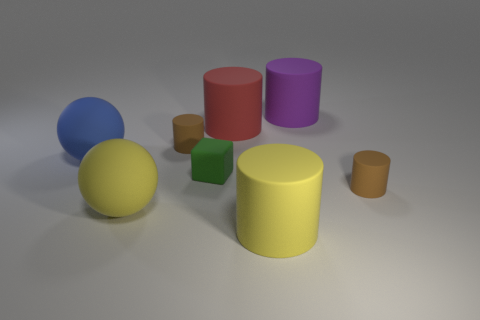Subtract all yellow cylinders. How many cylinders are left? 4 Subtract all big red matte cylinders. How many cylinders are left? 4 Subtract all gray cylinders. Subtract all red blocks. How many cylinders are left? 5 Add 1 tiny green matte cubes. How many objects exist? 9 Subtract all balls. How many objects are left? 6 Add 4 purple objects. How many purple objects are left? 5 Add 5 big blue things. How many big blue things exist? 6 Subtract 1 purple cylinders. How many objects are left? 7 Subtract all yellow metallic objects. Subtract all purple matte cylinders. How many objects are left? 7 